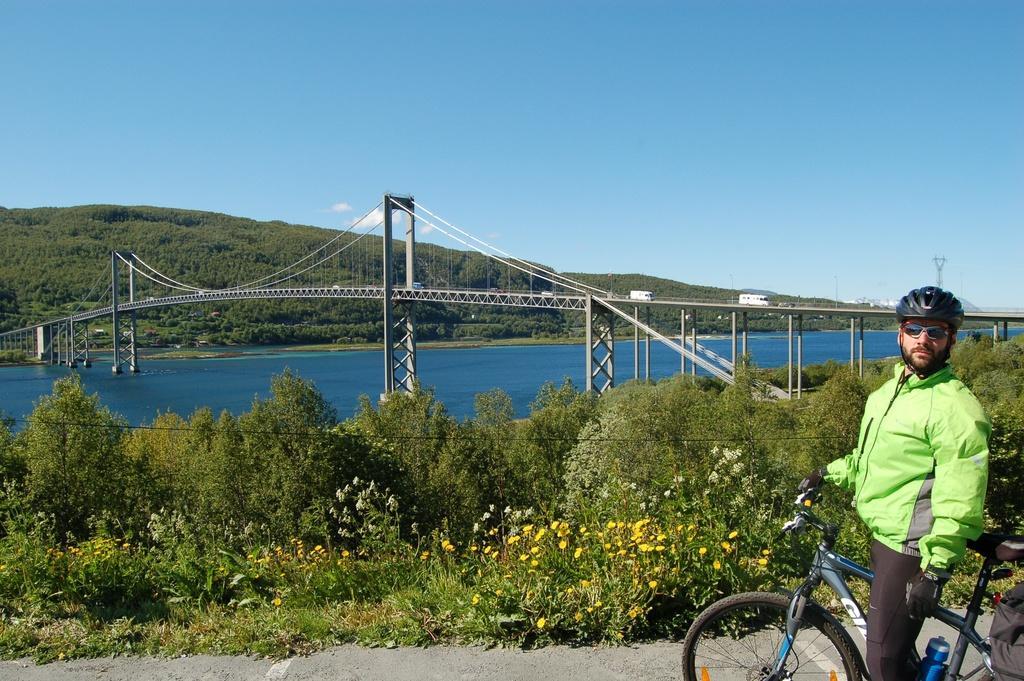Please provide a concise description of this image. There is a man standing and holding bicycle and wore helmet,glasses and gloves. We can see plants and flowers. Background we can see water,vehicles,bridge,trees and sky. 